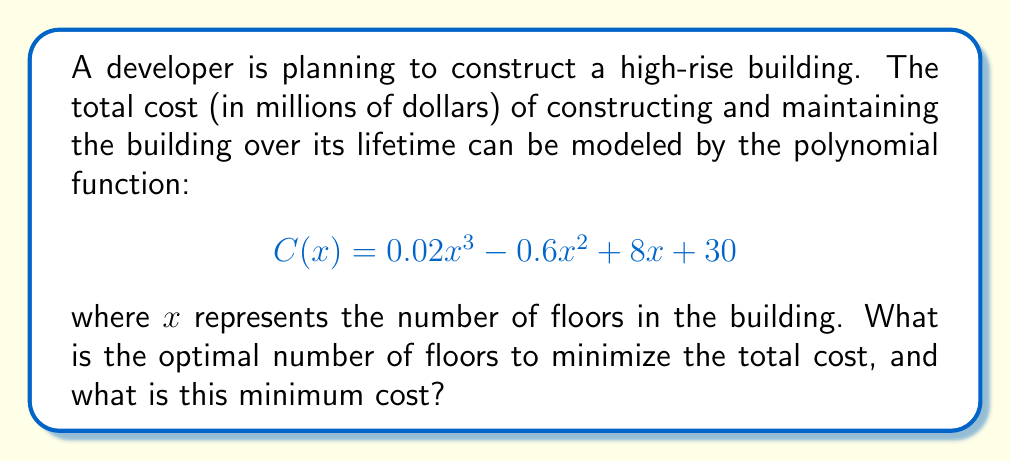Help me with this question. To find the optimal number of floors that minimizes the total cost, we need to find the minimum point of the cost function $C(x)$. This occurs where the derivative of $C(x)$ is zero.

1) First, let's find the derivative of $C(x)$:
   $$C'(x) = 0.06x^2 - 1.2x + 8$$

2) Set $C'(x) = 0$ and solve for $x$:
   $$0.06x^2 - 1.2x + 8 = 0$$

3) This is a quadratic equation. We can solve it using the quadratic formula:
   $$x = \frac{-b \pm \sqrt{b^2 - 4ac}}{2a}$$
   where $a = 0.06$, $b = -1.2$, and $c = 8$

4) Substituting these values:
   $$x = \frac{1.2 \pm \sqrt{(-1.2)^2 - 4(0.06)(8)}}{2(0.06)}$$
   $$= \frac{1.2 \pm \sqrt{1.44 - 1.92}}{0.12}$$
   $$= \frac{1.2 \pm \sqrt{-0.48}}{0.12}$$

5) Since the discriminant is negative, there are no real solutions. This means the function doesn't have a minimum or maximum point within the real number domain.

6) However, since we're dealing with building floors, we're only interested in positive integer values of $x$. In this case, we need to evaluate $C(x)$ for integer values of $x$ and find the minimum.

7) Let's evaluate $C(x)$ for some values:
   $C(1) = 0.02 - 0.6 + 8 + 30 = 37.42$
   $C(10) = 20 - 60 + 80 + 30 = 70$
   $C(20) = 160 - 240 + 160 + 30 = 110$

8) We can see that the cost is increasing as $x$ increases. Therefore, the minimum cost occurs at the smallest possible number of floors, which is 1.
Answer: The optimal number of floors to minimize the total cost is 1, and the minimum cost is $37.42 million. 